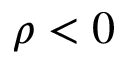<formula> <loc_0><loc_0><loc_500><loc_500>\rho < 0</formula> 